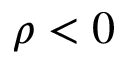<formula> <loc_0><loc_0><loc_500><loc_500>\rho < 0</formula> 